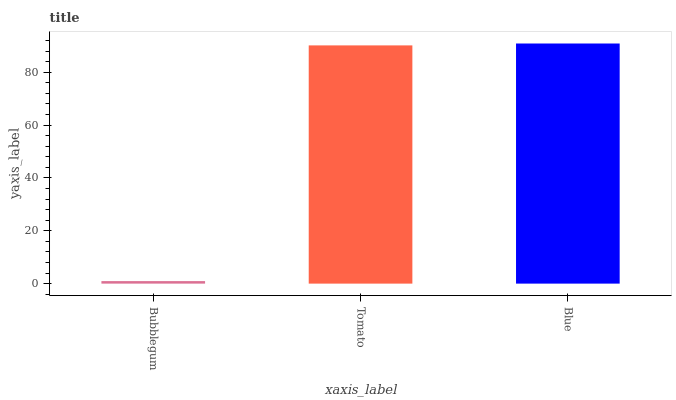Is Bubblegum the minimum?
Answer yes or no. Yes. Is Blue the maximum?
Answer yes or no. Yes. Is Tomato the minimum?
Answer yes or no. No. Is Tomato the maximum?
Answer yes or no. No. Is Tomato greater than Bubblegum?
Answer yes or no. Yes. Is Bubblegum less than Tomato?
Answer yes or no. Yes. Is Bubblegum greater than Tomato?
Answer yes or no. No. Is Tomato less than Bubblegum?
Answer yes or no. No. Is Tomato the high median?
Answer yes or no. Yes. Is Tomato the low median?
Answer yes or no. Yes. Is Blue the high median?
Answer yes or no. No. Is Blue the low median?
Answer yes or no. No. 